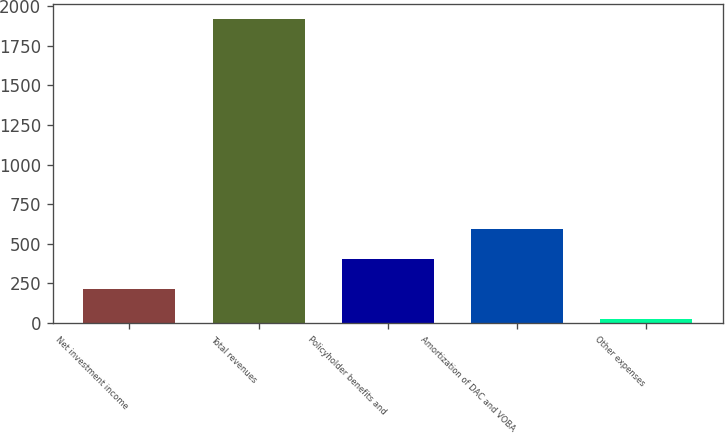Convert chart. <chart><loc_0><loc_0><loc_500><loc_500><bar_chart><fcel>Net investment income<fcel>Total revenues<fcel>Policyholder benefits and<fcel>Amortization of DAC and VOBA<fcel>Other expenses<nl><fcel>213.7<fcel>1921<fcel>403.4<fcel>593.1<fcel>24<nl></chart> 